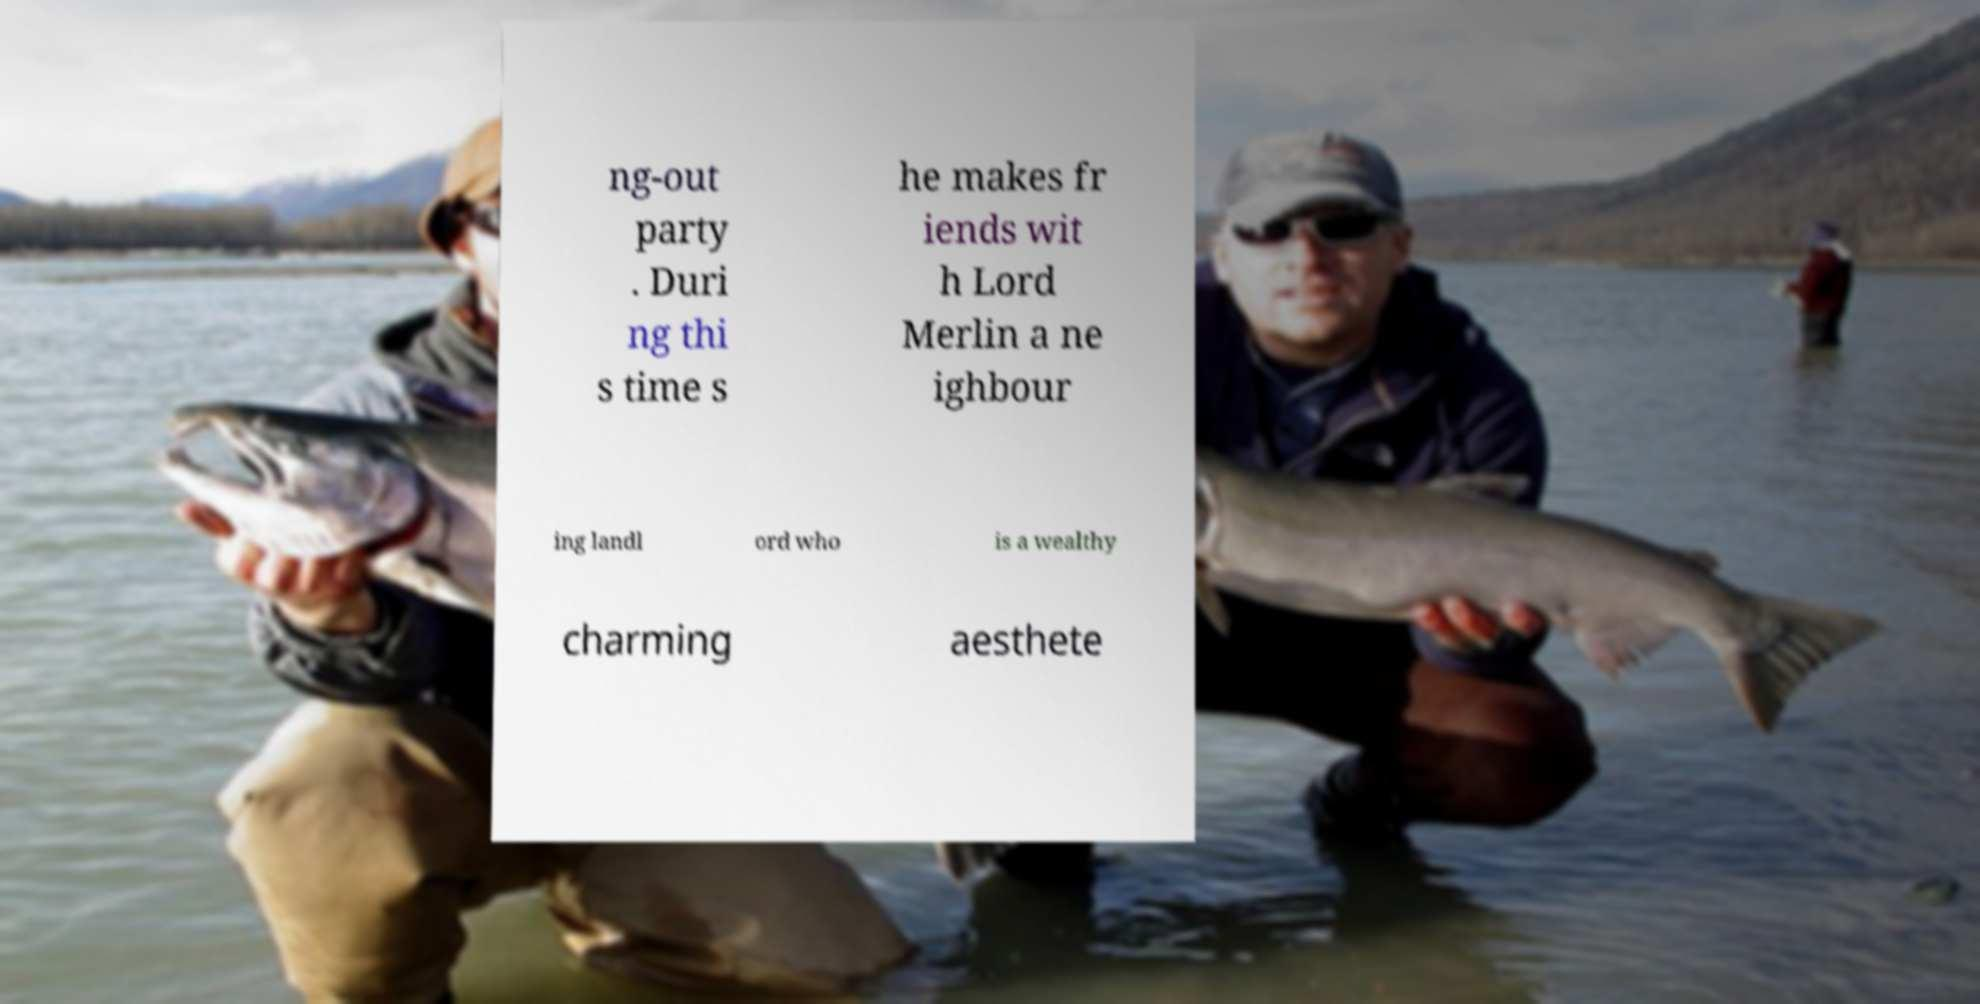Can you accurately transcribe the text from the provided image for me? ng-out party . Duri ng thi s time s he makes fr iends wit h Lord Merlin a ne ighbour ing landl ord who is a wealthy charming aesthete 